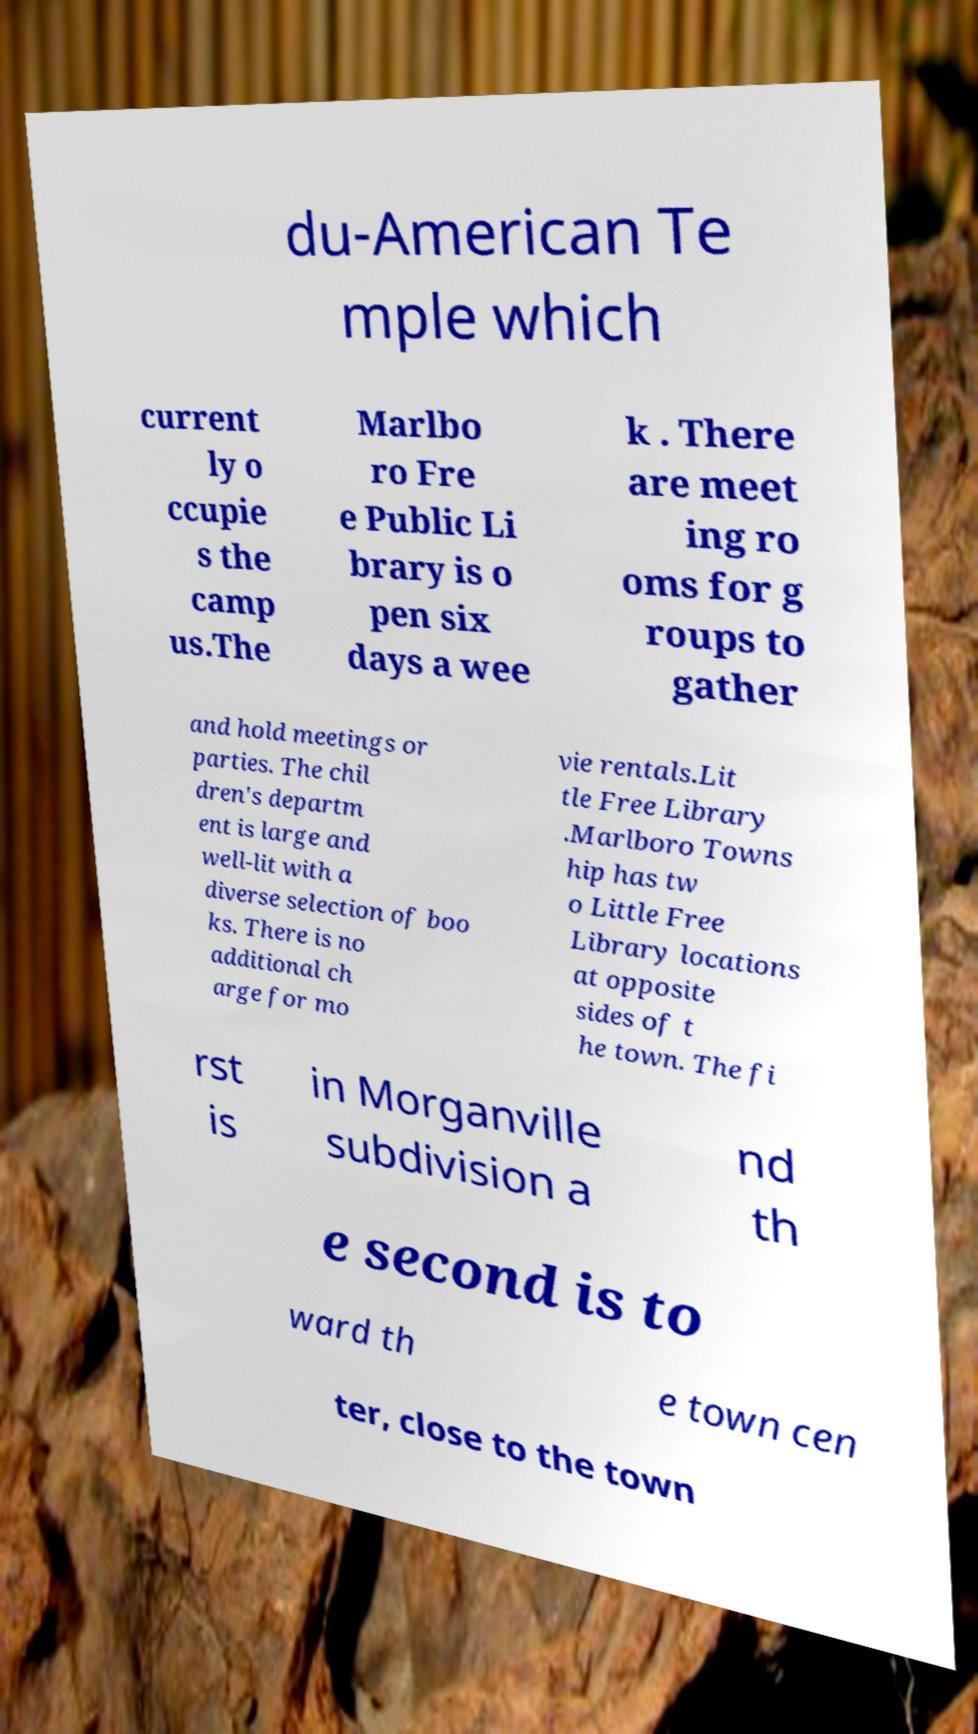For documentation purposes, I need the text within this image transcribed. Could you provide that? du-American Te mple which current ly o ccupie s the camp us.The Marlbo ro Fre e Public Li brary is o pen six days a wee k . There are meet ing ro oms for g roups to gather and hold meetings or parties. The chil dren's departm ent is large and well-lit with a diverse selection of boo ks. There is no additional ch arge for mo vie rentals.Lit tle Free Library .Marlboro Towns hip has tw o Little Free Library locations at opposite sides of t he town. The fi rst is in Morganville subdivision a nd th e second is to ward th e town cen ter, close to the town 